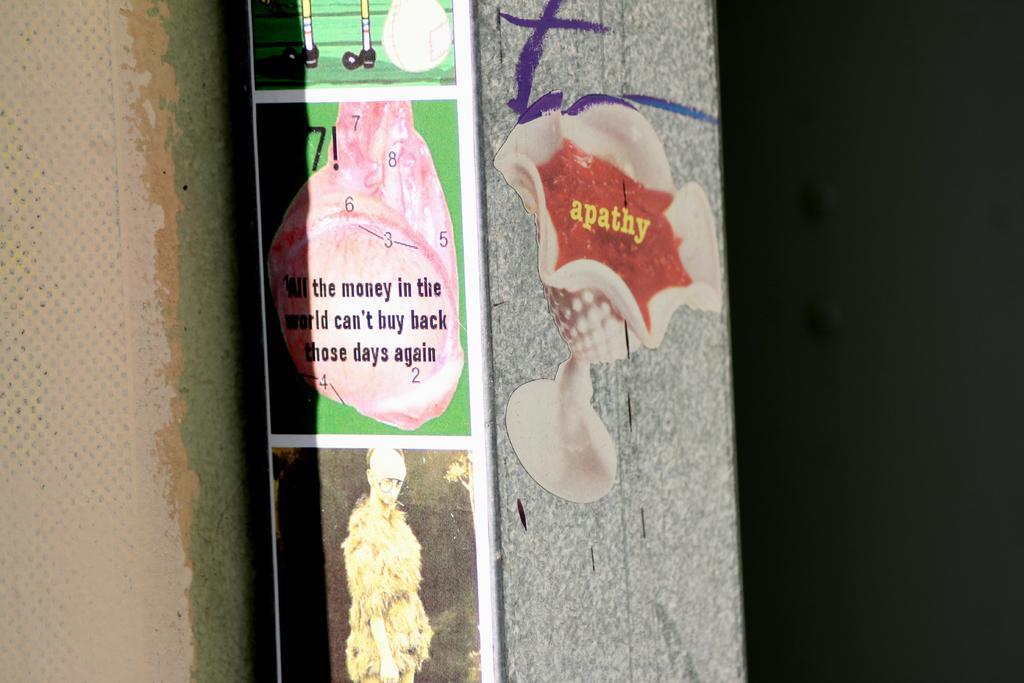In one or two sentences, can you explain what this image depicts? This picture shows few posts on the wall. 